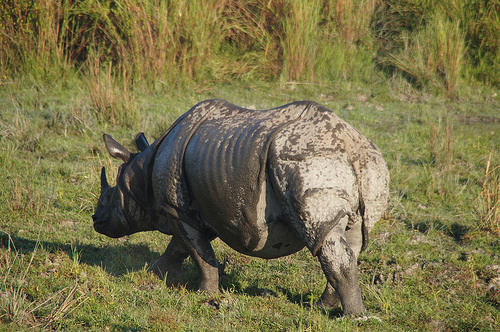<image>
Is there a butt behind the head? Yes. From this viewpoint, the butt is positioned behind the head, with the head partially or fully occluding the butt. 